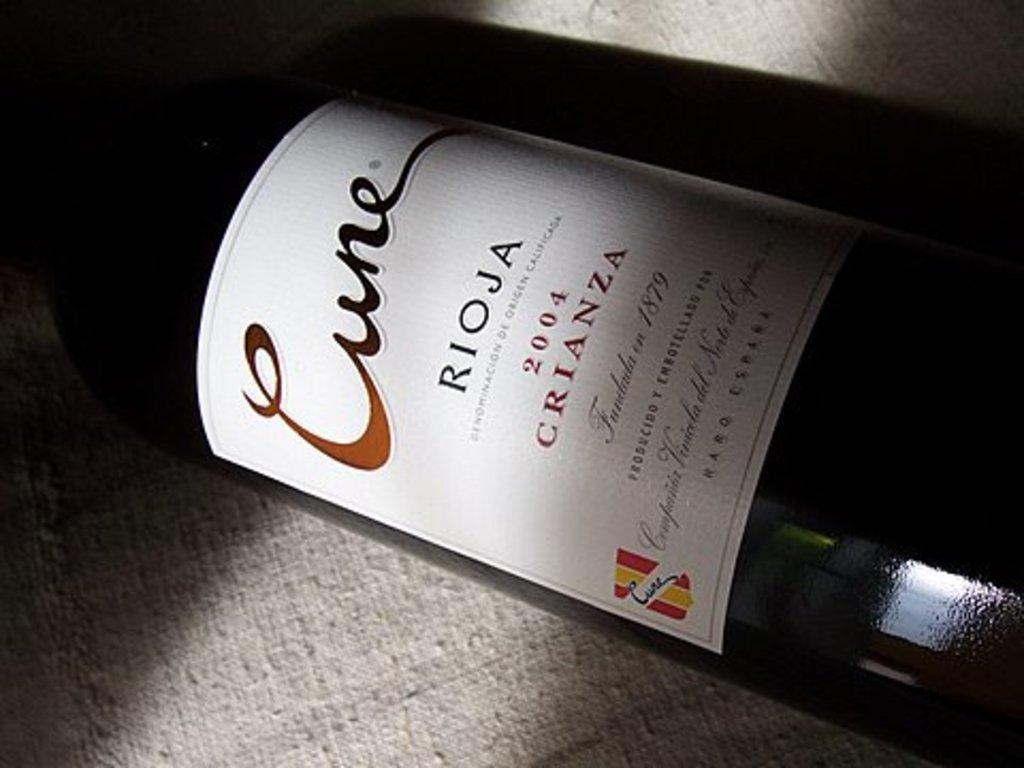Provide a one-sentence caption for the provided image. The year on this bottle of wine is 2004. 